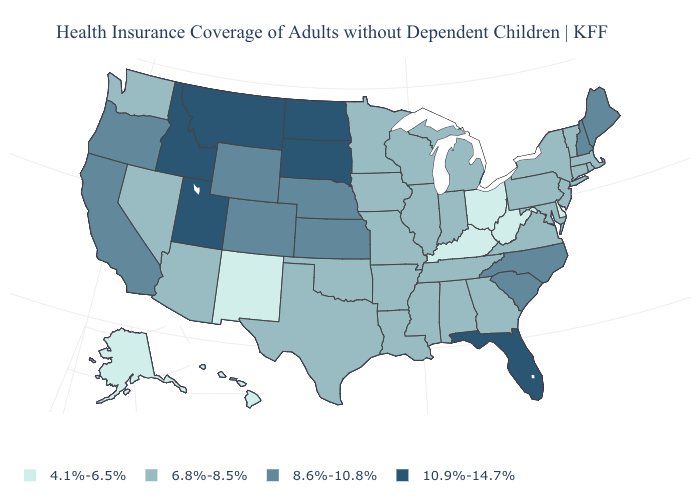What is the highest value in the West ?
Keep it brief. 10.9%-14.7%. Does the map have missing data?
Concise answer only. No. Among the states that border Utah , does Arizona have the highest value?
Keep it brief. No. What is the lowest value in states that border South Carolina?
Quick response, please. 6.8%-8.5%. How many symbols are there in the legend?
Concise answer only. 4. Name the states that have a value in the range 8.6%-10.8%?
Write a very short answer. California, Colorado, Kansas, Maine, Nebraska, New Hampshire, North Carolina, Oregon, South Carolina, Wyoming. Name the states that have a value in the range 10.9%-14.7%?
Write a very short answer. Florida, Idaho, Montana, North Dakota, South Dakota, Utah. Name the states that have a value in the range 10.9%-14.7%?
Be succinct. Florida, Idaho, Montana, North Dakota, South Dakota, Utah. Among the states that border South Carolina , which have the highest value?
Keep it brief. North Carolina. Name the states that have a value in the range 10.9%-14.7%?
Quick response, please. Florida, Idaho, Montana, North Dakota, South Dakota, Utah. What is the lowest value in states that border Rhode Island?
Quick response, please. 6.8%-8.5%. Which states hav the highest value in the South?
Keep it brief. Florida. What is the lowest value in the USA?
Short answer required. 4.1%-6.5%. Does Louisiana have a higher value than Utah?
Answer briefly. No. What is the lowest value in states that border West Virginia?
Keep it brief. 4.1%-6.5%. 